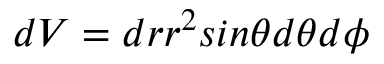<formula> <loc_0><loc_0><loc_500><loc_500>d V = d r r ^ { 2 } \sin \theta d \theta d \phi</formula> 